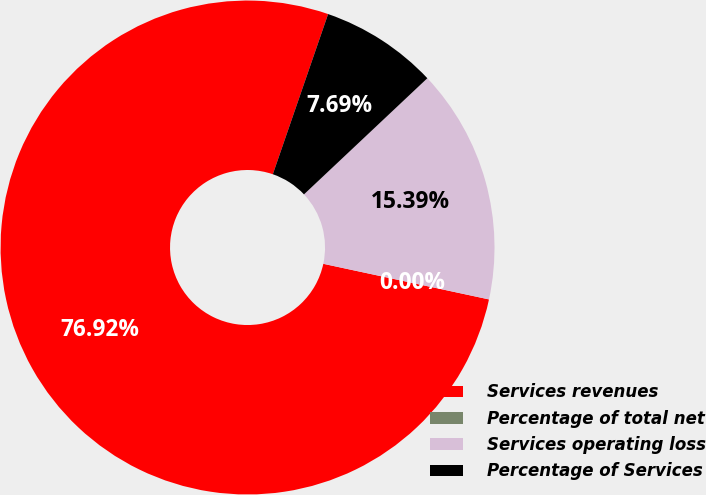<chart> <loc_0><loc_0><loc_500><loc_500><pie_chart><fcel>Services revenues<fcel>Percentage of total net<fcel>Services operating loss<fcel>Percentage of Services<nl><fcel>76.92%<fcel>0.0%<fcel>15.39%<fcel>7.69%<nl></chart> 